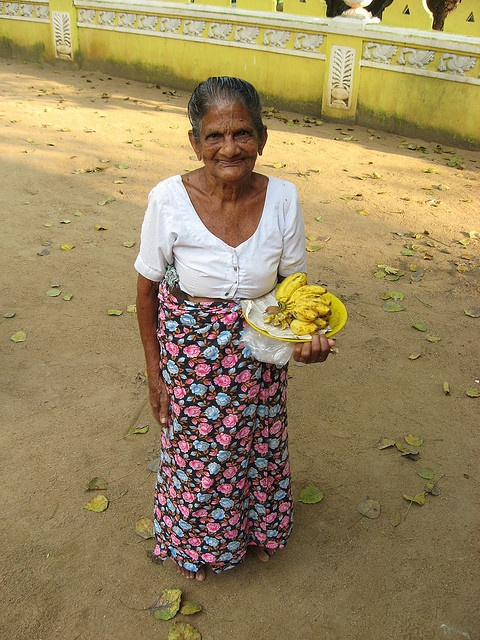Describe the objects in this image and their specific colors. I can see people in olive, black, lightgray, brown, and maroon tones and banana in olive and gold tones in this image. 